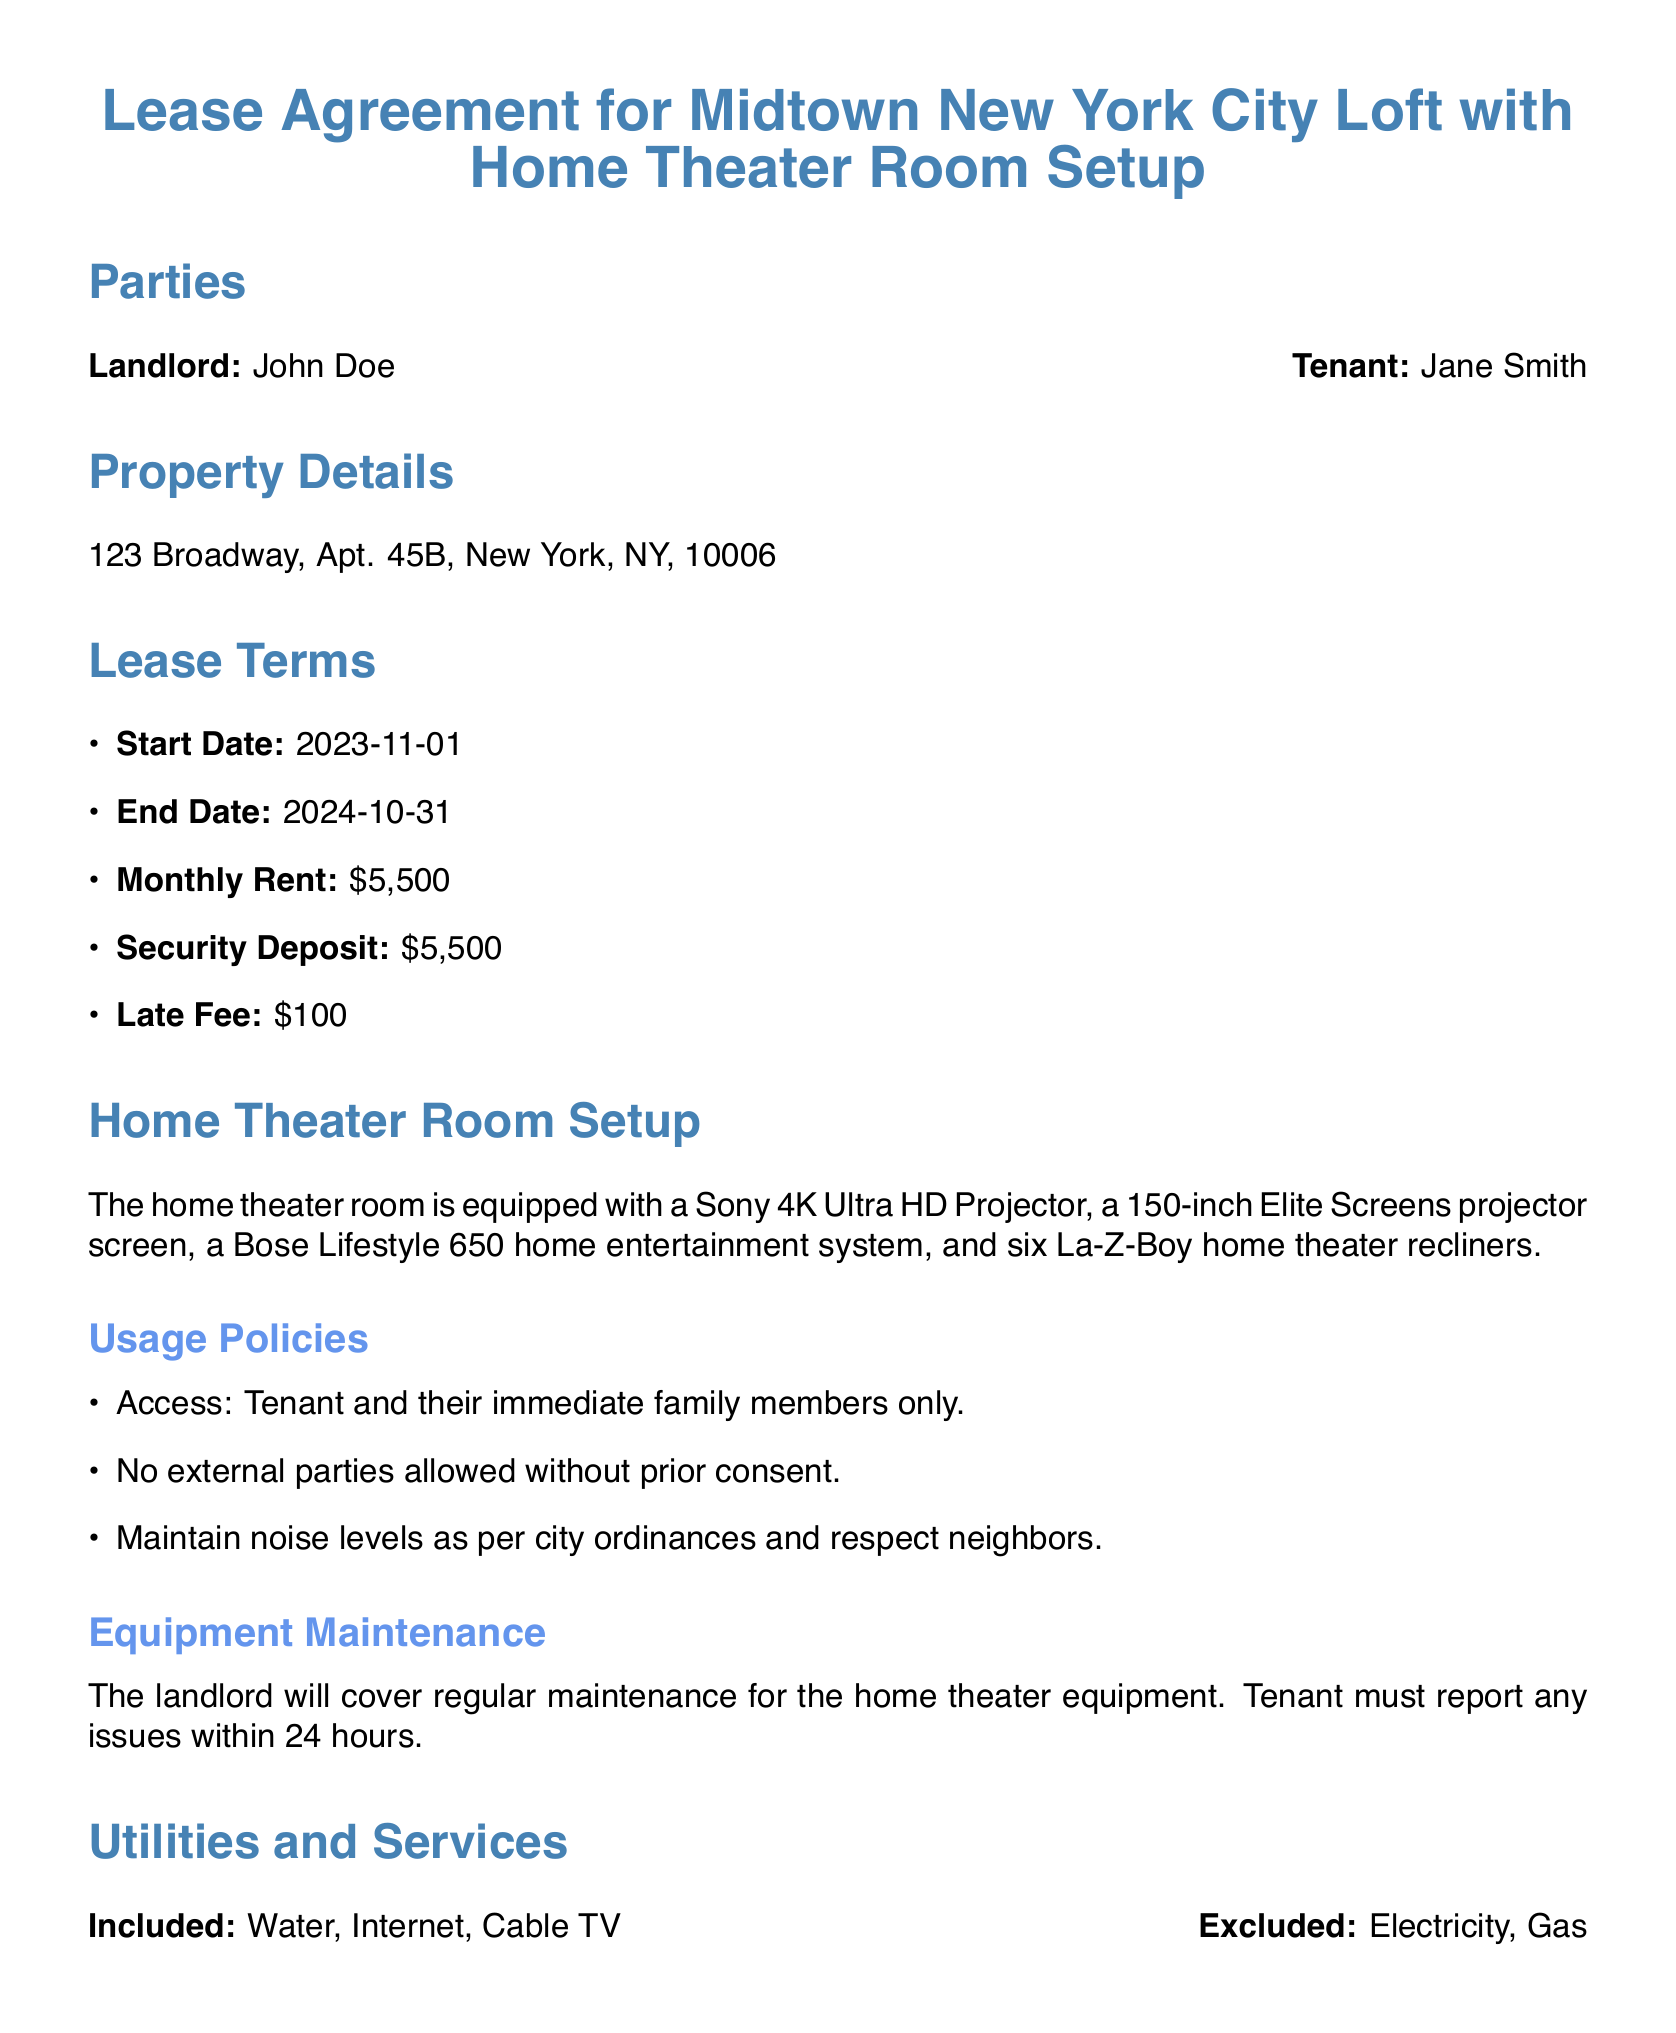What is the Landlord's name? The document provides the name of the landlord, which is John Doe.
Answer: John Doe What is the monthly rent? The lease agreement states that the monthly rent for the loft is specified in the lease terms section.
Answer: $5,500 When does the lease start? The start date of the lease is mentioned under the Lease Terms section of the document.
Answer: 2023-11-01 How much is the security deposit? The amount for the security deposit is indicated in the Lease Terms section.
Answer: $5,500 Who is allowed access to the home theater room? The usage policies detail who is permitted to access the home theater room.
Answer: Tenant and their immediate family members only What equipment is provided in the home theater room? The document lists specific equipment in the home theater room under the Home Theater Room Setup section.
Answer: Sony 4K Ultra HD Projector, 150-inch Elite Screens projector screen, Bose Lifestyle 650 home entertainment system, six La-Z-Boy recliners What is the late fee for overdue rent? The lease agreement mentions any penalties for late rent payments in the Lease Terms section.
Answer: $100 What are the Tenant's obligations? The lease outlines what the tenant is required to do, detailed in the Tenant Obligations section.
Answer: Obtain renter's insurance and maintain cleanliness of the loft What utilities are included? The lease specifies included utilities in the Utilities and Services section.
Answer: Water, Internet, Cable TV How much notice must the landlord provide before entry? The Landlord's obligations discuss the required notice period the landlord must give.
Answer: 24-hour notice 